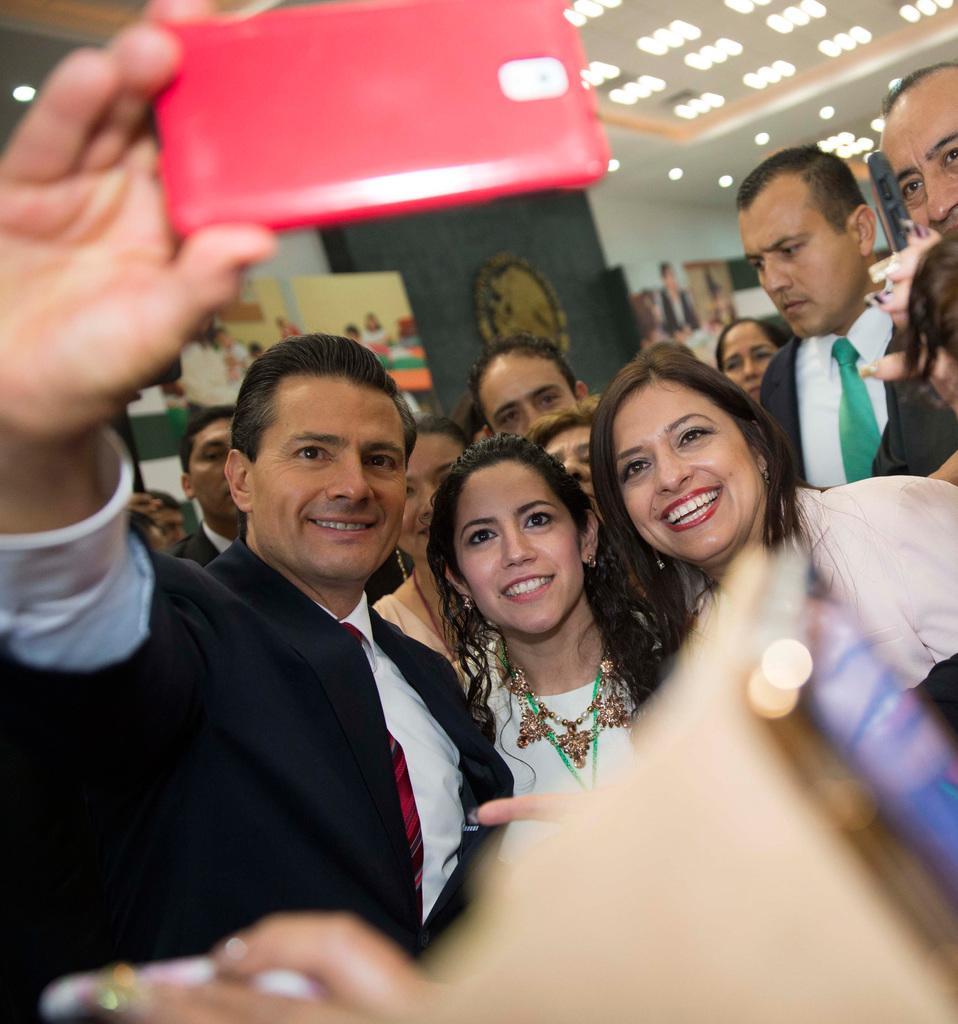Could you give a brief overview of what you see in this image? In this image there are three persons standing, in which one person is holding a mobile, and in the background there are group of people standing, frames attached to the wall, lights. 